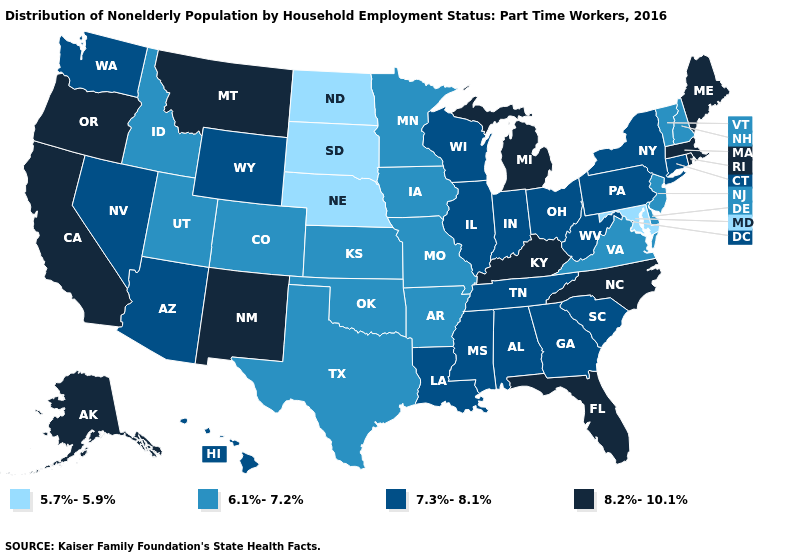Does Georgia have the lowest value in the USA?
Keep it brief. No. What is the value of Michigan?
Keep it brief. 8.2%-10.1%. Does Ohio have the same value as Washington?
Keep it brief. Yes. Does Wyoming have the same value as Colorado?
Give a very brief answer. No. Which states have the lowest value in the MidWest?
Keep it brief. Nebraska, North Dakota, South Dakota. What is the lowest value in the South?
Answer briefly. 5.7%-5.9%. Name the states that have a value in the range 7.3%-8.1%?
Keep it brief. Alabama, Arizona, Connecticut, Georgia, Hawaii, Illinois, Indiana, Louisiana, Mississippi, Nevada, New York, Ohio, Pennsylvania, South Carolina, Tennessee, Washington, West Virginia, Wisconsin, Wyoming. Does the map have missing data?
Write a very short answer. No. What is the lowest value in states that border Georgia?
Give a very brief answer. 7.3%-8.1%. What is the value of Maine?
Answer briefly. 8.2%-10.1%. What is the lowest value in the West?
Write a very short answer. 6.1%-7.2%. What is the value of Virginia?
Write a very short answer. 6.1%-7.2%. What is the highest value in the Northeast ?
Keep it brief. 8.2%-10.1%. How many symbols are there in the legend?
Write a very short answer. 4. Does Alaska have the highest value in the USA?
Quick response, please. Yes. 